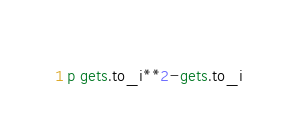<code> <loc_0><loc_0><loc_500><loc_500><_Ruby_>p gets.to_i**2-gets.to_i</code> 